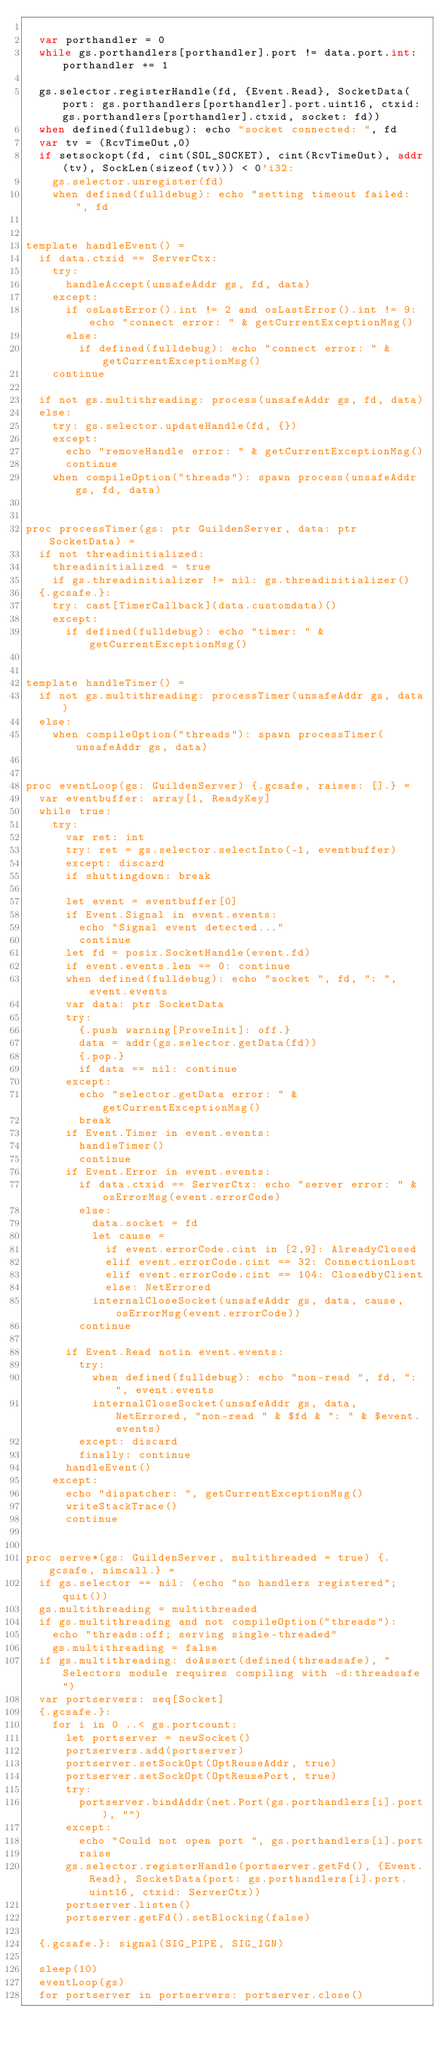Convert code to text. <code><loc_0><loc_0><loc_500><loc_500><_Nim_>
  var porthandler = 0
  while gs.porthandlers[porthandler].port != data.port.int: porthandler += 1
  
  gs.selector.registerHandle(fd, {Event.Read}, SocketData(port: gs.porthandlers[porthandler].port.uint16, ctxid: gs.porthandlers[porthandler].ctxid, socket: fd))
  when defined(fulldebug): echo "socket connected: ", fd
  var tv = (RcvTimeOut,0)
  if setsockopt(fd, cint(SOL_SOCKET), cint(RcvTimeOut), addr(tv), SockLen(sizeof(tv))) < 0'i32:
    gs.selector.unregister(fd)
    when defined(fulldebug): echo "setting timeout failed: ", fd


template handleEvent() =
  if data.ctxid == ServerCtx:
    try:
      handleAccept(unsafeAddr gs, fd, data)
    except:
      if osLastError().int != 2 and osLastError().int != 9: echo "connect error: " & getCurrentExceptionMsg()
      else:
        if defined(fulldebug): echo "connect error: " & getCurrentExceptionMsg()
    continue

  if not gs.multithreading: process(unsafeAddr gs, fd, data)
  else:
    try: gs.selector.updateHandle(fd, {})
    except:
      echo "removeHandle error: " & getCurrentExceptionMsg()
      continue
    when compileOption("threads"): spawn process(unsafeAddr gs, fd, data)


proc processTimer(gs: ptr GuildenServer, data: ptr SocketData) =
  if not threadinitialized:
    threadinitialized = true
    if gs.threadinitializer != nil: gs.threadinitializer()
  {.gcsafe.}:  
    try: cast[TimerCallback](data.customdata)()
    except:
      if defined(fulldebug): echo "timer: " & getCurrentExceptionMsg()


template handleTimer() =
  if not gs.multithreading: processTimer(unsafeAddr gs, data)
  else:
    when compileOption("threads"): spawn processTimer(unsafeAddr gs, data)
  

proc eventLoop(gs: GuildenServer) {.gcsafe, raises: [].} =
  var eventbuffer: array[1, ReadyKey]
  while true:
    try:
      var ret: int
      try: ret = gs.selector.selectInto(-1, eventbuffer)
      except: discard    
      if shuttingdown: break
      
      let event = eventbuffer[0]
      if Event.Signal in event.events:
        echo "Signal event detected..."
        continue
      let fd = posix.SocketHandle(event.fd)
      if event.events.len == 0: continue
      when defined(fulldebug): echo "socket ", fd, ": ", event.events
      var data: ptr SocketData
      try:
        {.push warning[ProveInit]: off.}
        data = addr(gs.selector.getData(fd))
        {.pop.}
        if data == nil: continue
      except:
        echo "selector.getData error: " & getCurrentExceptionMsg()
        break
      if Event.Timer in event.events:
        handleTimer()
        continue
      if Event.Error in event.events:
        if data.ctxid == ServerCtx: echo "server error: " & osErrorMsg(event.errorCode)
        else:
          data.socket = fd
          let cause =
            if event.errorCode.cint in [2,9]: AlreadyClosed
            elif event.errorCode.cint == 32: ConnectionLost
            elif event.errorCode.cint == 104: ClosedbyClient
            else: NetErrored 
          internalCloseSocket(unsafeAddr gs, data, cause, osErrorMsg(event.errorCode))
        continue

      if Event.Read notin event.events:
        try:
          when defined(fulldebug): echo "non-read ", fd, ": ", event.events
          internalCloseSocket(unsafeAddr gs, data, NetErrored, "non-read " & $fd & ": " & $event.events)        
        except: discard
        finally: continue       
      handleEvent()
    except:
      echo "dispatcher: ", getCurrentExceptionMsg()
      writeStackTrace()
      continue


proc serve*(gs: GuildenServer, multithreaded = true) {.gcsafe, nimcall.} =
  if gs.selector == nil: (echo "no handlers registered"; quit())
  gs.multithreading = multithreaded
  if gs.multithreading and not compileOption("threads"):
    echo "threads:off; serving single-threaded"
    gs.multithreading = false
  if gs.multithreading: doAssert(defined(threadsafe), "Selectors module requires compiling with -d:threadsafe")
  var portservers: seq[Socket]
  {.gcsafe.}:
    for i in 0 ..< gs.portcount:
      let portserver = newSocket()
      portservers.add(portserver)
      portserver.setSockOpt(OptReuseAddr, true)
      portserver.setSockOpt(OptReusePort, true)
      try:
        portserver.bindAddr(net.Port(gs.porthandlers[i].port), "")
      except:
        echo "Could not open port ", gs.porthandlers[i].port
        raise
      gs.selector.registerHandle(portserver.getFd(), {Event.Read}, SocketData(port: gs.porthandlers[i].port.uint16, ctxid: ServerCtx))
      portserver.listen()
      portserver.getFd().setBlocking(false)

  {.gcsafe.}: signal(SIG_PIPE, SIG_IGN)
  
  sleep(10)
  eventLoop(gs)
  for portserver in portservers: portserver.close()</code> 